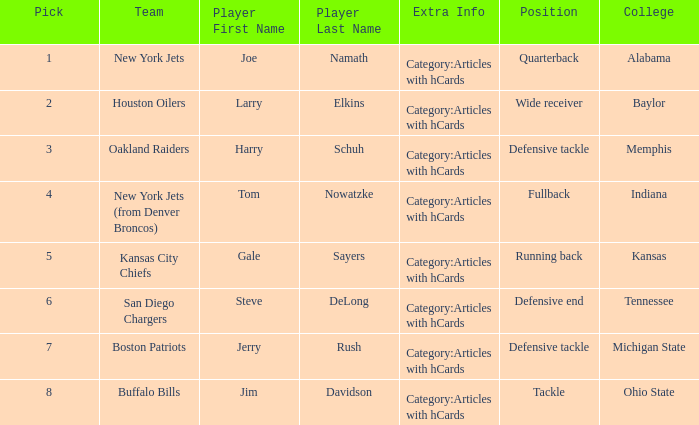The New York Jets picked someone from what college? Alabama. Could you parse the entire table? {'header': ['Pick', 'Team', 'Player First Name', 'Player Last Name', 'Extra Info', 'Position', 'College'], 'rows': [['1', 'New York Jets', 'Joe', 'Namath', 'Category:Articles with hCards', 'Quarterback', 'Alabama'], ['2', 'Houston Oilers', 'Larry', 'Elkins', 'Category:Articles with hCards', 'Wide receiver', 'Baylor'], ['3', 'Oakland Raiders', 'Harry', 'Schuh', 'Category:Articles with hCards', 'Defensive tackle', 'Memphis'], ['4', 'New York Jets (from Denver Broncos)', 'Tom', 'Nowatzke', 'Category:Articles with hCards', 'Fullback', 'Indiana'], ['5', 'Kansas City Chiefs', 'Gale', 'Sayers', 'Category:Articles with hCards', 'Running back', 'Kansas'], ['6', 'San Diego Chargers', 'Steve', 'DeLong', 'Category:Articles with hCards', 'Defensive end', 'Tennessee'], ['7', 'Boston Patriots', 'Jerry', 'Rush', 'Category:Articles with hCards', 'Defensive tackle', 'Michigan State'], ['8', 'Buffalo Bills', 'Jim', 'Davidson', 'Category:Articles with hCards', 'Tackle', 'Ohio State']]} 